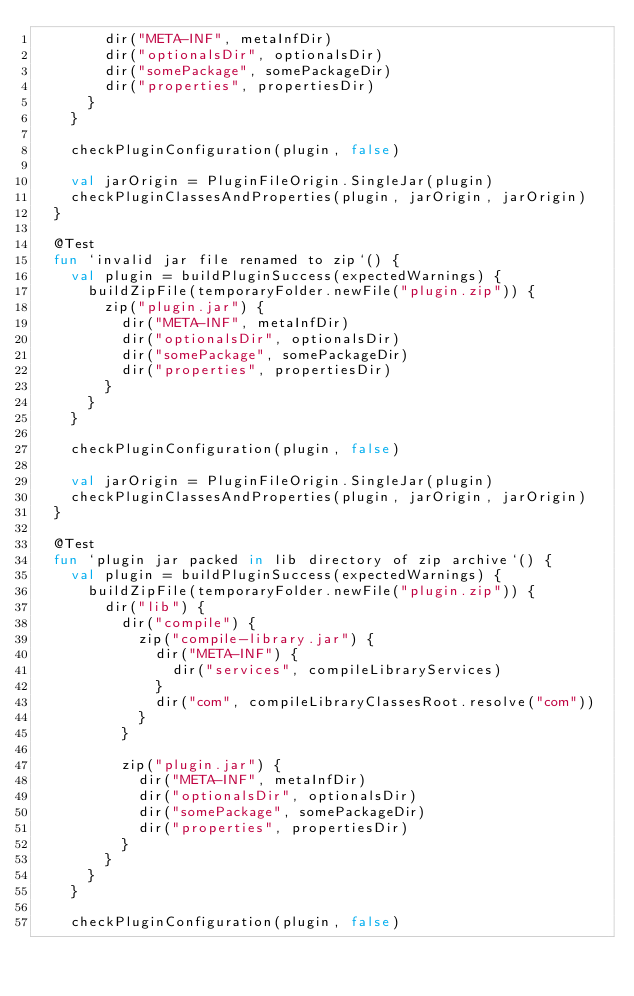<code> <loc_0><loc_0><loc_500><loc_500><_Kotlin_>        dir("META-INF", metaInfDir)
        dir("optionalsDir", optionalsDir)
        dir("somePackage", somePackageDir)
        dir("properties", propertiesDir)
      }
    }

    checkPluginConfiguration(plugin, false)

    val jarOrigin = PluginFileOrigin.SingleJar(plugin)
    checkPluginClassesAndProperties(plugin, jarOrigin, jarOrigin)
  }

  @Test
  fun `invalid jar file renamed to zip`() {
    val plugin = buildPluginSuccess(expectedWarnings) {
      buildZipFile(temporaryFolder.newFile("plugin.zip")) {
        zip("plugin.jar") {
          dir("META-INF", metaInfDir)
          dir("optionalsDir", optionalsDir)
          dir("somePackage", somePackageDir)
          dir("properties", propertiesDir)
        }
      }
    }

    checkPluginConfiguration(plugin, false)

    val jarOrigin = PluginFileOrigin.SingleJar(plugin)
    checkPluginClassesAndProperties(plugin, jarOrigin, jarOrigin)
  }

  @Test
  fun `plugin jar packed in lib directory of zip archive`() {
    val plugin = buildPluginSuccess(expectedWarnings) {
      buildZipFile(temporaryFolder.newFile("plugin.zip")) {
        dir("lib") {
          dir("compile") {
            zip("compile-library.jar") {
              dir("META-INF") {
                dir("services", compileLibraryServices)
              }
              dir("com", compileLibraryClassesRoot.resolve("com"))
            }
          }

          zip("plugin.jar") {
            dir("META-INF", metaInfDir)
            dir("optionalsDir", optionalsDir)
            dir("somePackage", somePackageDir)
            dir("properties", propertiesDir)
          }
        }
      }
    }

    checkPluginConfiguration(plugin, false)
</code> 